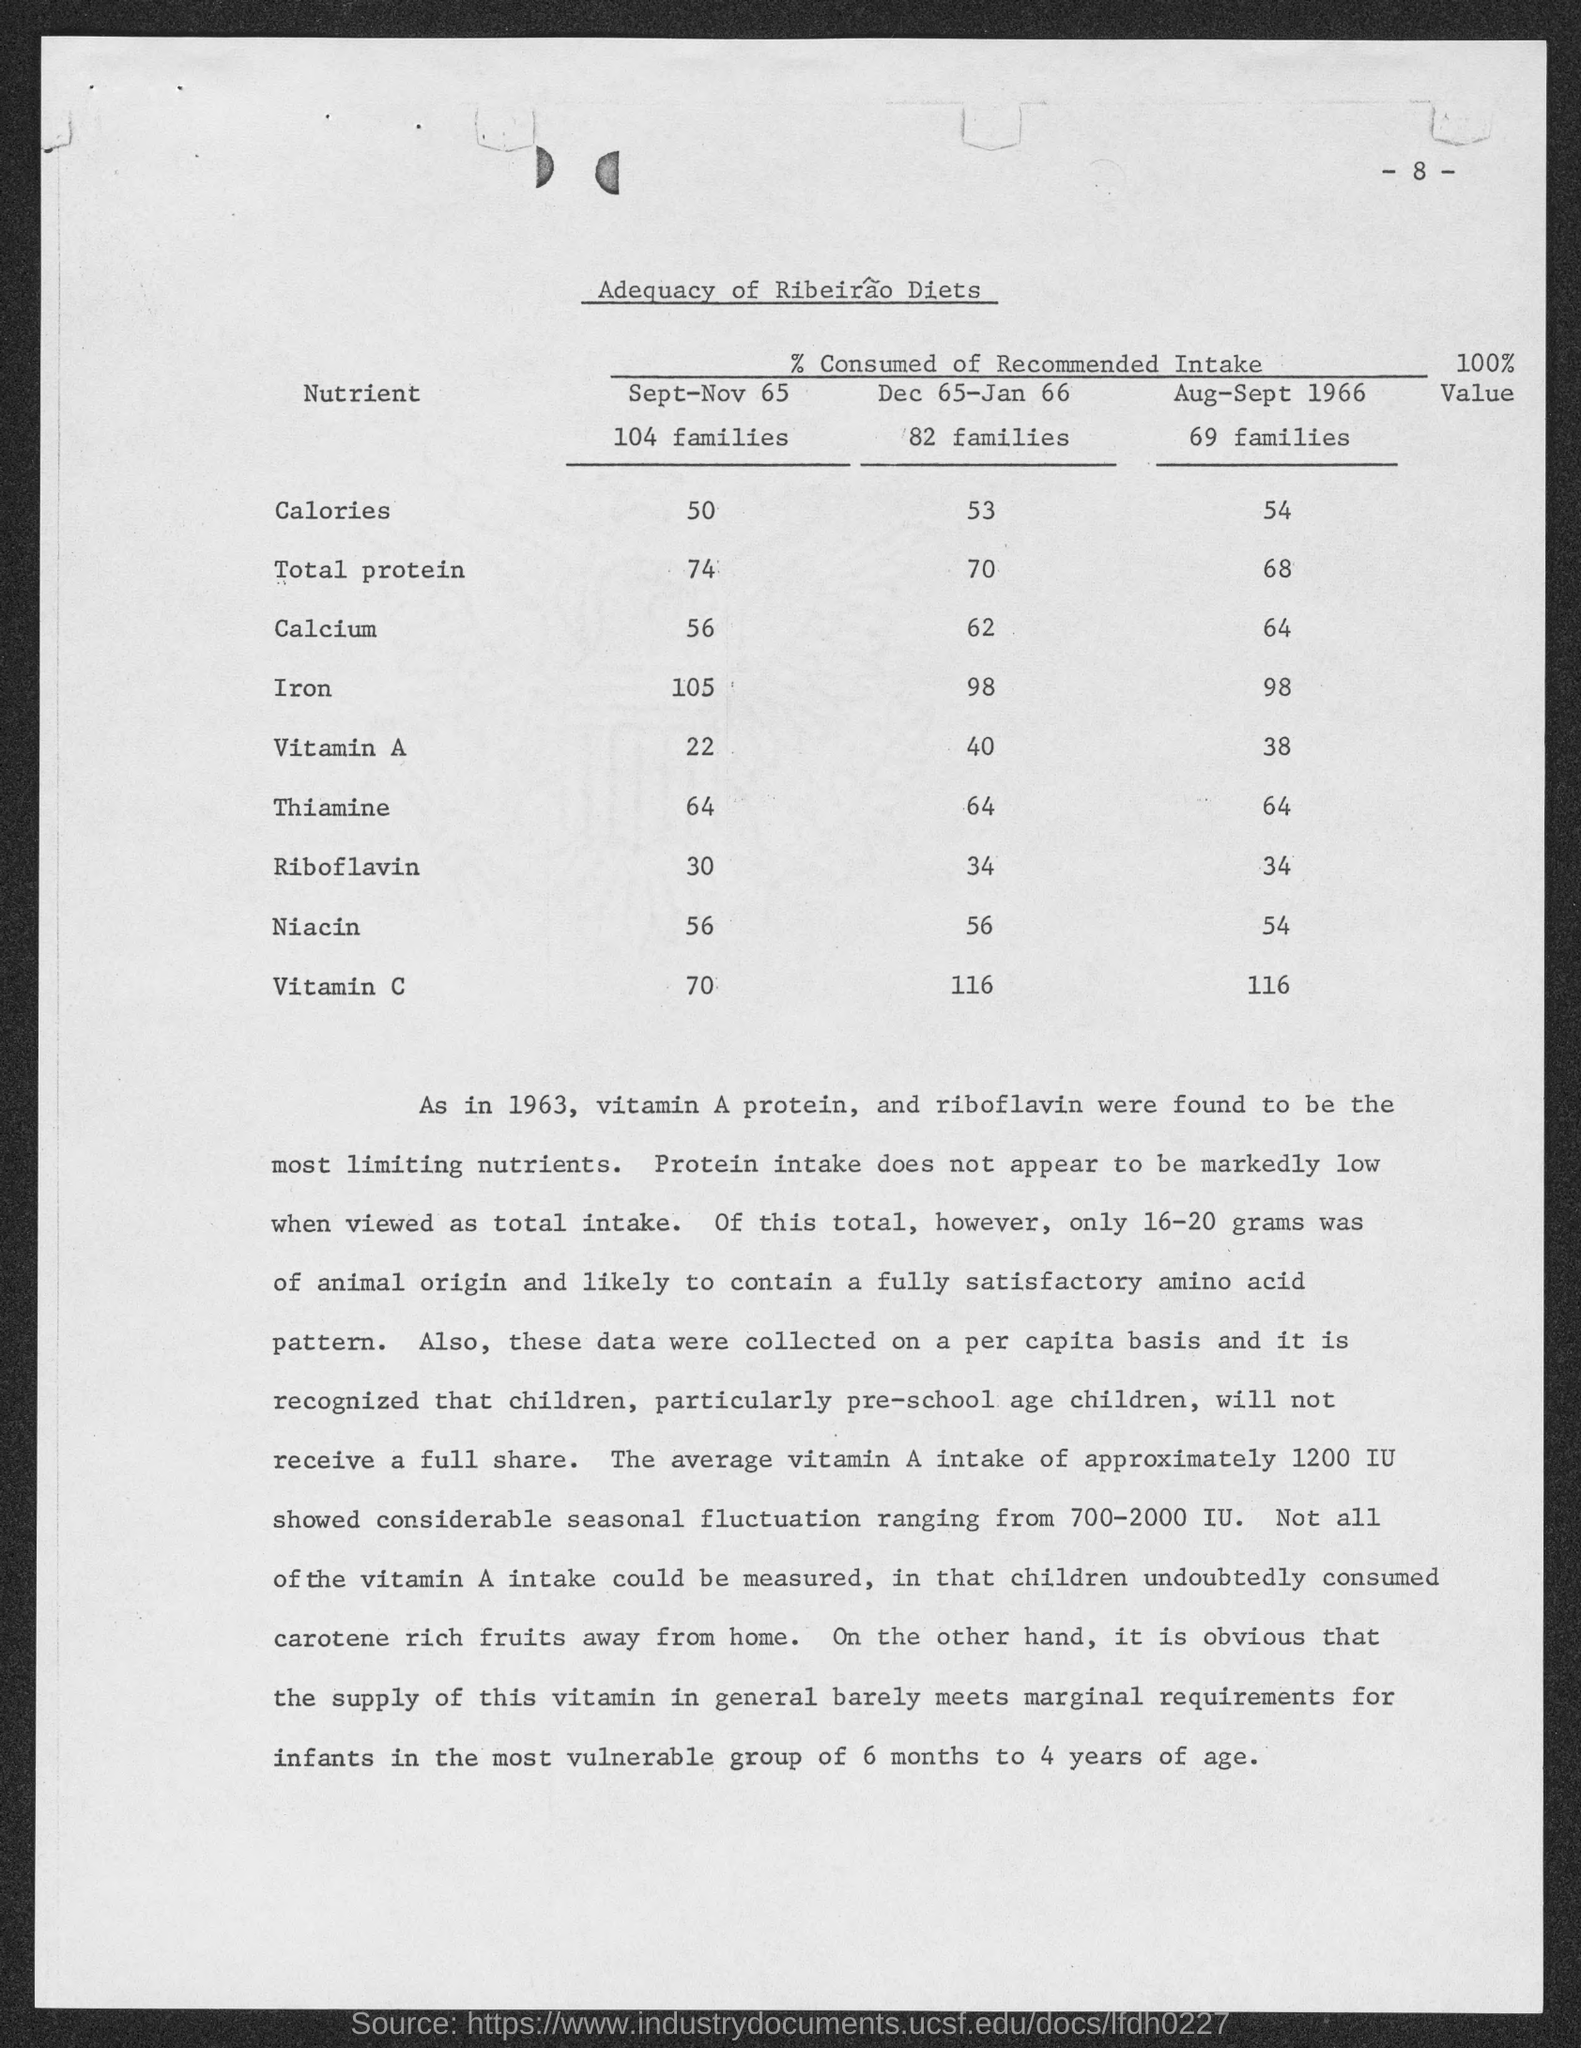Identify some key points in this picture. In the period from August to September 1966, a total of 69 families were considered. This page number is 8.. During the period of December 1965 to January 1966, there were 82 families considered. During the period of September to November 1965, a total of 104 families were considered. 